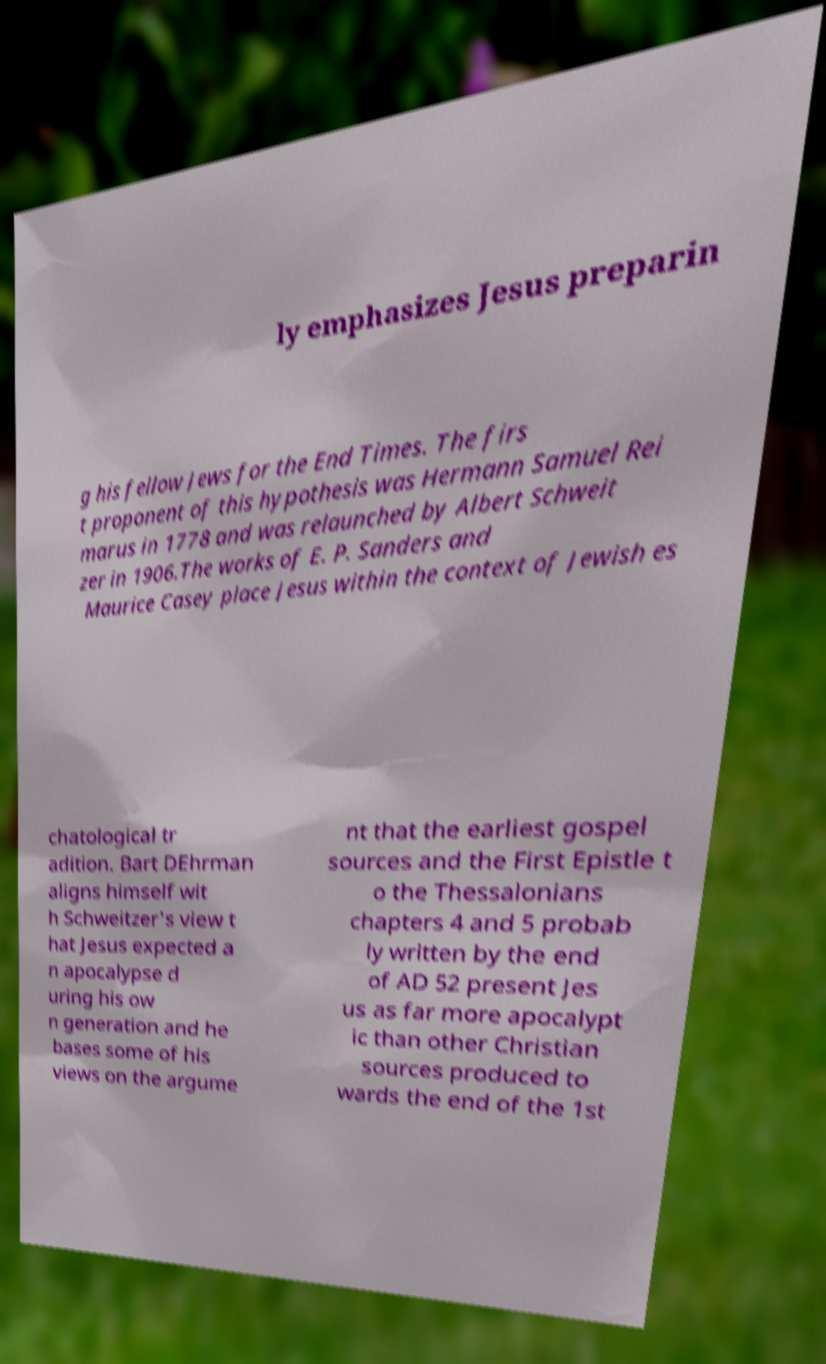Could you extract and type out the text from this image? ly emphasizes Jesus preparin g his fellow Jews for the End Times. The firs t proponent of this hypothesis was Hermann Samuel Rei marus in 1778 and was relaunched by Albert Schweit zer in 1906.The works of E. P. Sanders and Maurice Casey place Jesus within the context of Jewish es chatological tr adition. Bart DEhrman aligns himself wit h Schweitzer's view t hat Jesus expected a n apocalypse d uring his ow n generation and he bases some of his views on the argume nt that the earliest gospel sources and the First Epistle t o the Thessalonians chapters 4 and 5 probab ly written by the end of AD 52 present Jes us as far more apocalypt ic than other Christian sources produced to wards the end of the 1st 